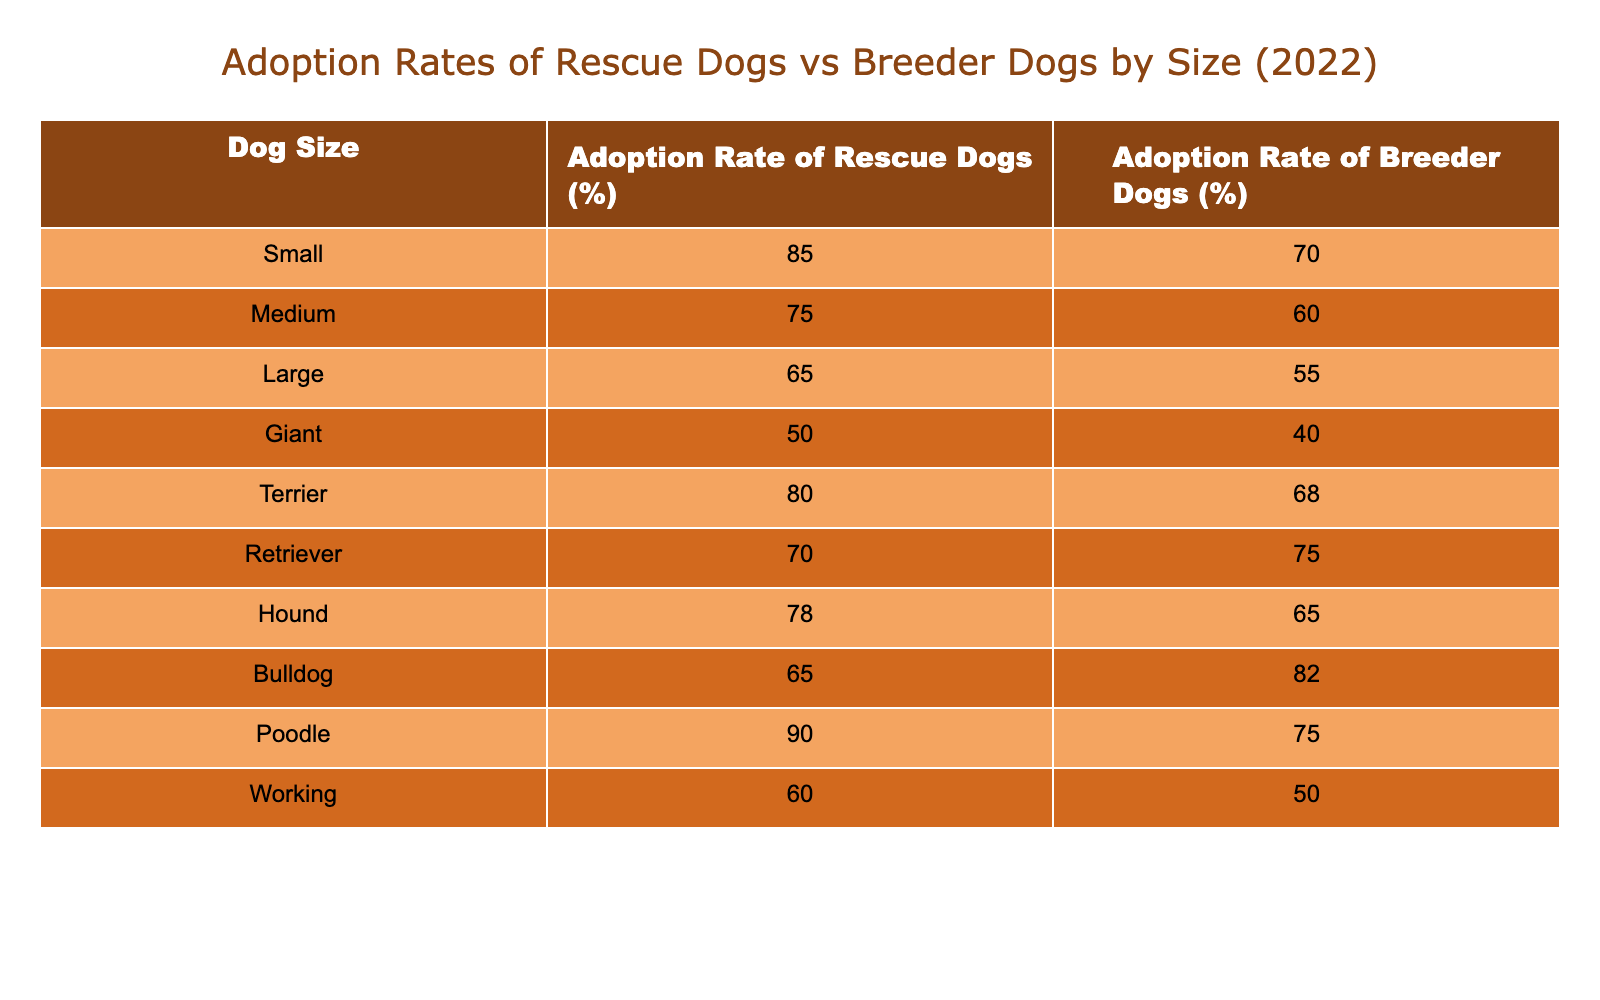What is the adoption rate of small rescue dogs? According to the table, the adoption rate of small rescue dogs is listed under the "Adoption Rate of Rescue Dogs (%)" for the Small size category, which is 85%.
Answer: 85% What is the adoption rate of medium breed dogs from breeders? The table indicates that the adoption rate of breeder dogs in the Medium size category is 60%, as mentioned in the "Adoption Rate of Breeder Dogs (%)" column.
Answer: 60% Which size of rescue dog has the lowest adoption rate? By reviewing the "Adoption Rate of Rescue Dogs (%)" column, the Giant size category shows the lowest adoption rate at 50%.
Answer: 50% What is the difference in adoption rates between terrier rescue dogs and bulldog breeder dogs? The adoption rate of terrier rescue dogs is 80%, and for bulldog breeder dogs, it is 82%. The difference is calculated as 80% - 82%, which equals -2%.
Answer: -2% What is the average adoption rate of rescue dogs? To find the average, sum the adoption rates for rescue dogs (85 + 75 + 65 + 50 + 80 + 70 + 78 + 65 + 90 + 60 =  75.3), and then divide by the number of sizes (10). So, the average adoption rate of rescue dogs is 75.3%.
Answer: 75.3% Do larger rescue dogs (large and giant) have higher adoption rates than smaller rescue dogs (small and medium)? The total adoption rate for large and giant rescue dogs is (65 + 50 = 115%), while for small and medium it is (85 + 75 = 160%). Since 160% is greater than 115%, the statement is false.
Answer: No Which group has a higher adoption rate: rescue dogs or breeder dogs? By looking at the table, the total adoption rate for rescue dogs (sum = 75.3%) is higher than the total for breeder dogs (sum = 66.5%).
Answer: Yes What is the combined adoption rate for working and giant rescue dogs? By summing the adoption rates for working (60%) and giant (50%) rescue dogs, we calculate 60% + 50% = 110%.
Answer: 110% Which type of rescue dog has a significantly higher adoption rate than its breeder counterpart? Observing the table, Poodle rescue dogs have an adoption rate of 90%, while Poodle breeder dogs have a rate of 75%. The difference of 15% indicates a significantly higher adoption rate.
Answer: Poodle Is the adoption rate for all hound breed dogs (rescue and breeder) greater than 75%? The adoption rate for hound rescue dogs is 78% and for hound breeder dogs is 65%. Since 65% is less than 75%, the statement is false.
Answer: No 